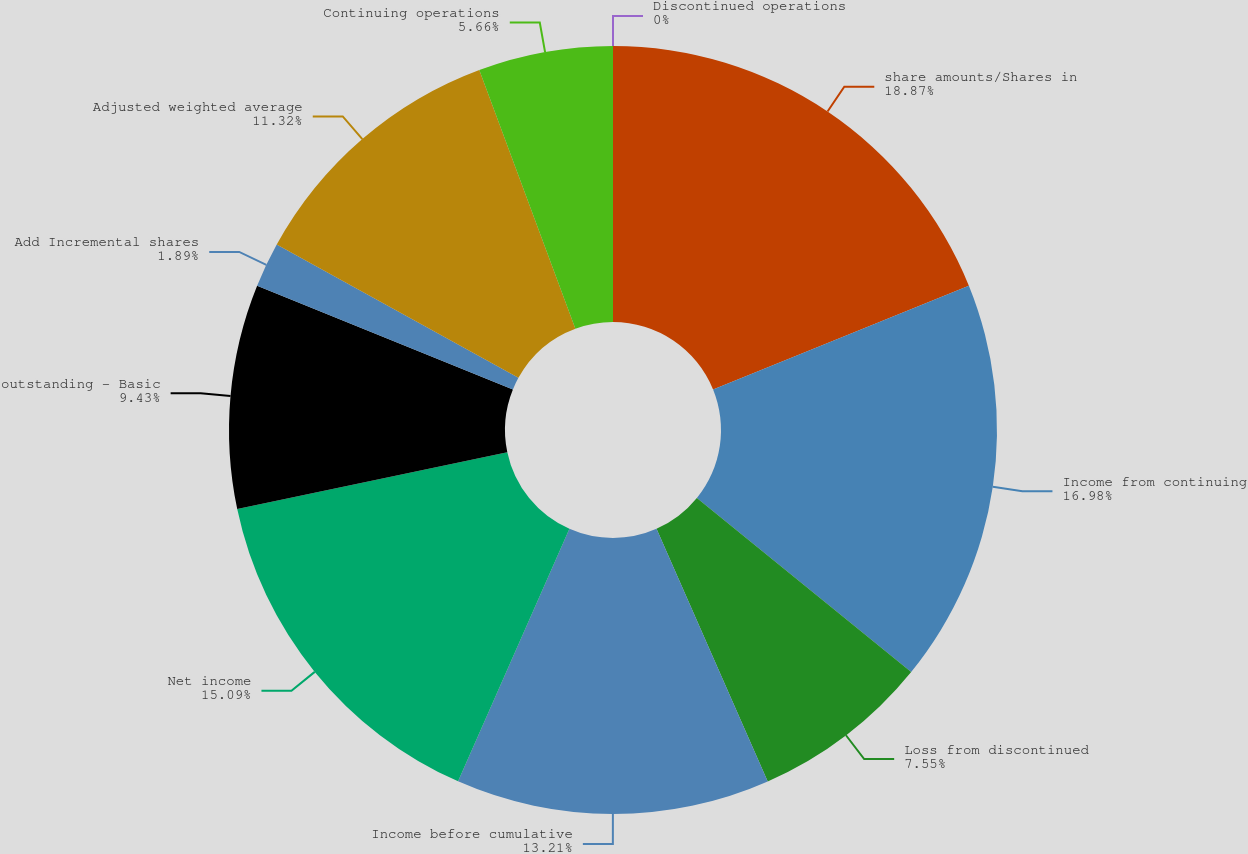Convert chart. <chart><loc_0><loc_0><loc_500><loc_500><pie_chart><fcel>share amounts/Shares in<fcel>Income from continuing<fcel>Loss from discontinued<fcel>Income before cumulative<fcel>Net income<fcel>outstanding - Basic<fcel>Add Incremental shares<fcel>Adjusted weighted average<fcel>Continuing operations<fcel>Discontinued operations<nl><fcel>18.87%<fcel>16.98%<fcel>7.55%<fcel>13.21%<fcel>15.09%<fcel>9.43%<fcel>1.89%<fcel>11.32%<fcel>5.66%<fcel>0.0%<nl></chart> 